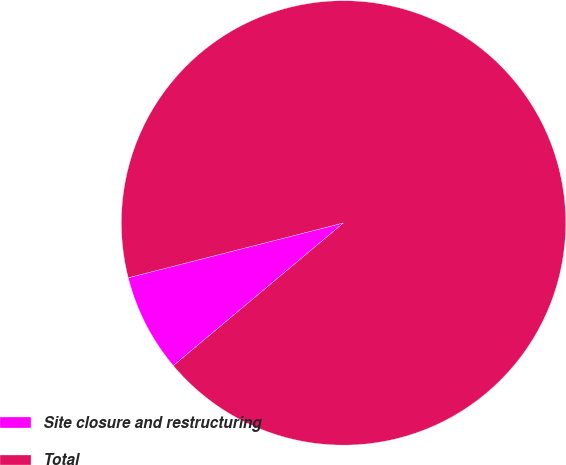Convert chart to OTSL. <chart><loc_0><loc_0><loc_500><loc_500><pie_chart><fcel>Site closure and restructuring<fcel>Total<nl><fcel>7.14%<fcel>92.86%<nl></chart> 